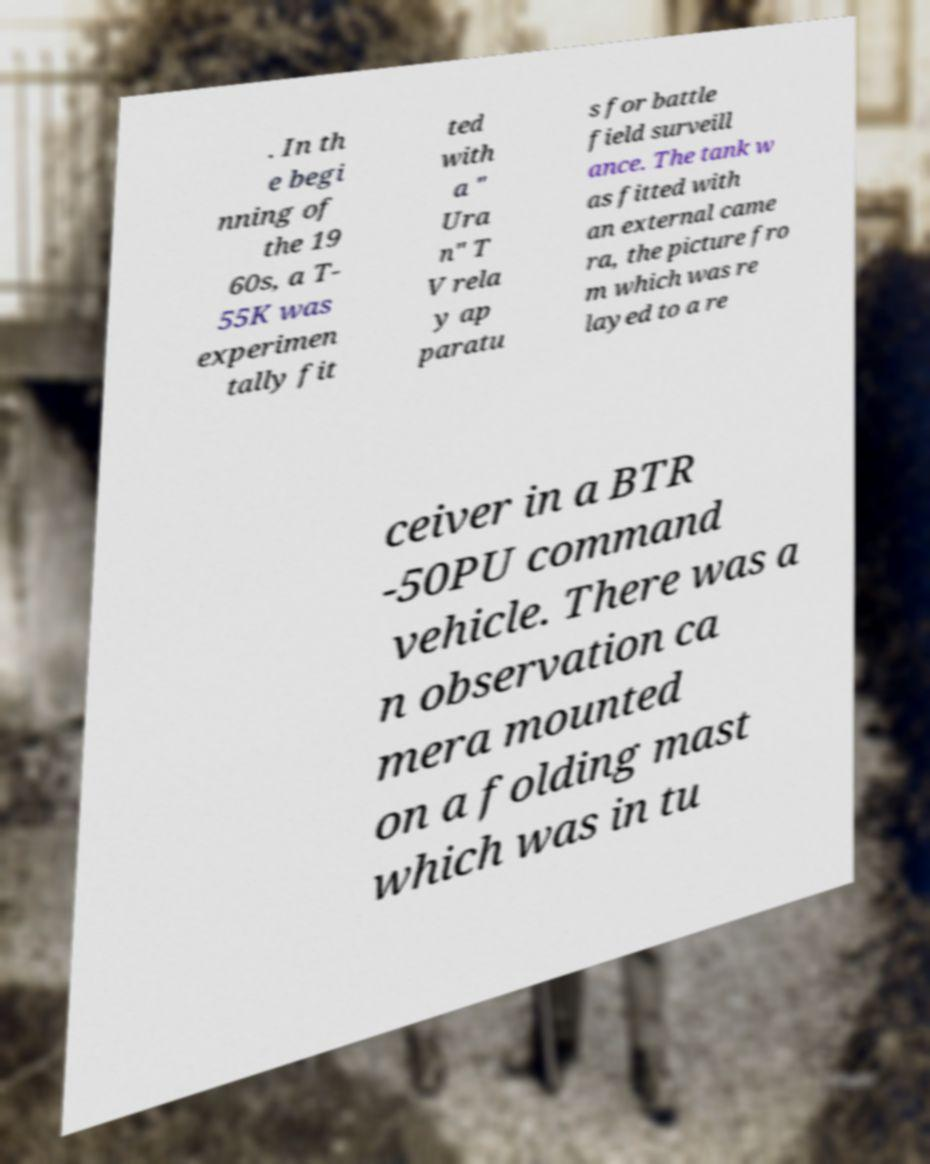Can you accurately transcribe the text from the provided image for me? . In th e begi nning of the 19 60s, a T- 55K was experimen tally fit ted with a " Ura n" T V rela y ap paratu s for battle field surveill ance. The tank w as fitted with an external came ra, the picture fro m which was re layed to a re ceiver in a BTR -50PU command vehicle. There was a n observation ca mera mounted on a folding mast which was in tu 